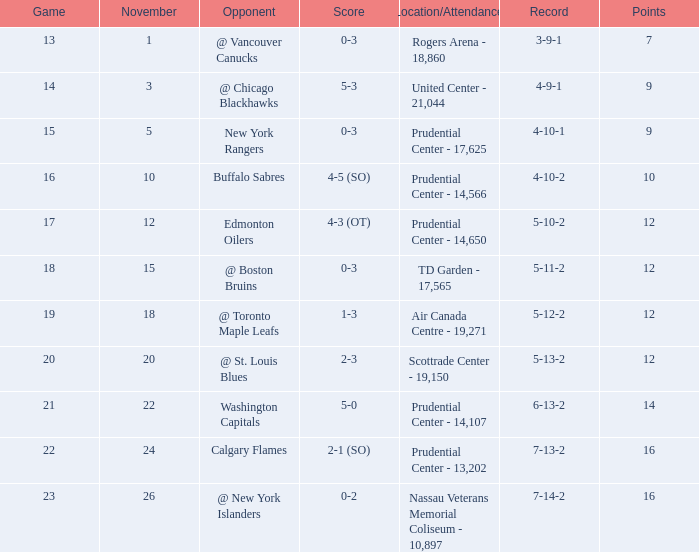What is the count of locations with a rating of 1 to 3? 1.0. 